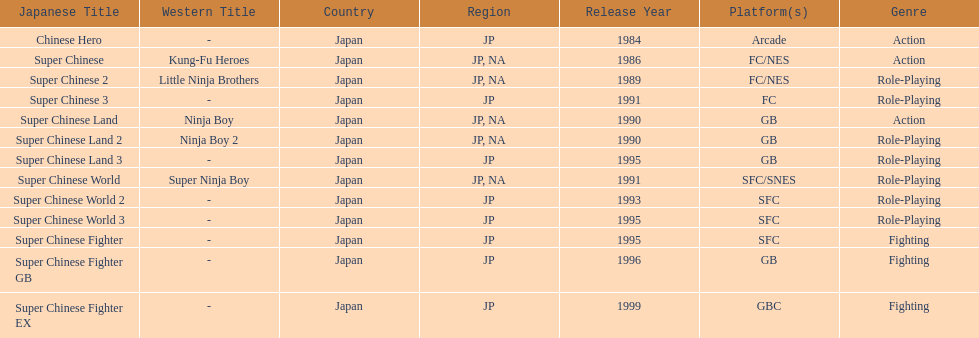The first year a game was released in north america 1986. 